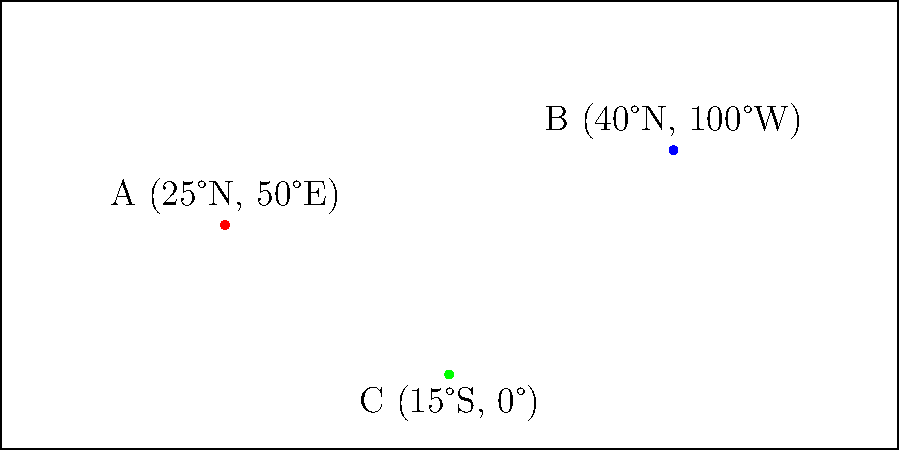As an attaché fostering cultural exchange, you're tasked with plotting three diplomatic missions on a world map. Given the following coordinates:

A: 25°N, 50°E
B: 40°N, 100°W
C: 15°S, 0°

Which mission is located closest to the Prime Meridian (0° longitude)? To determine which mission is closest to the Prime Meridian, we need to compare the absolute values of the longitudes:

1. Mission A: 50°E
   Absolute value: |50°| = 50°

2. Mission B: 100°W
   Absolute value: |100°| = 100°

3. Mission C: 0°
   Absolute value: |0°| = 0°

The Prime Meridian is at 0° longitude. The mission with the smallest absolute longitude value will be closest to the Prime Meridian.

Comparing the values:
0° < 50° < 100°

Therefore, Mission C, located at 15°S, 0°, is closest to the Prime Meridian.
Answer: Mission C (15°S, 0°) 